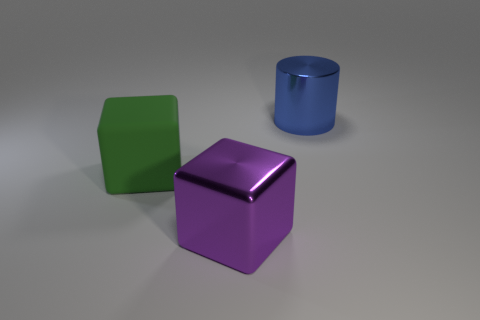Add 3 big objects. How many objects exist? 6 Subtract all cylinders. How many objects are left? 2 Add 1 purple metal cubes. How many purple metal cubes exist? 2 Subtract 0 cyan cylinders. How many objects are left? 3 Subtract all tiny cyan matte cubes. Subtract all blue cylinders. How many objects are left? 2 Add 3 big shiny cubes. How many big shiny cubes are left? 4 